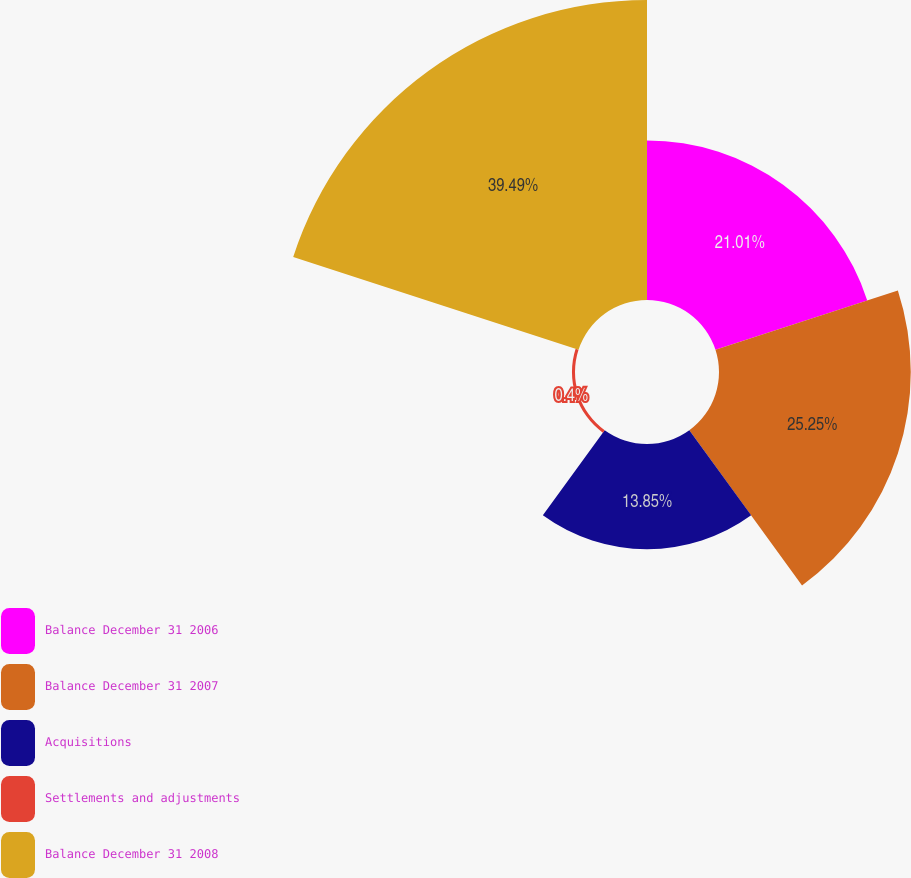<chart> <loc_0><loc_0><loc_500><loc_500><pie_chart><fcel>Balance December 31 2006<fcel>Balance December 31 2007<fcel>Acquisitions<fcel>Settlements and adjustments<fcel>Balance December 31 2008<nl><fcel>21.01%<fcel>25.25%<fcel>13.85%<fcel>0.4%<fcel>39.5%<nl></chart> 